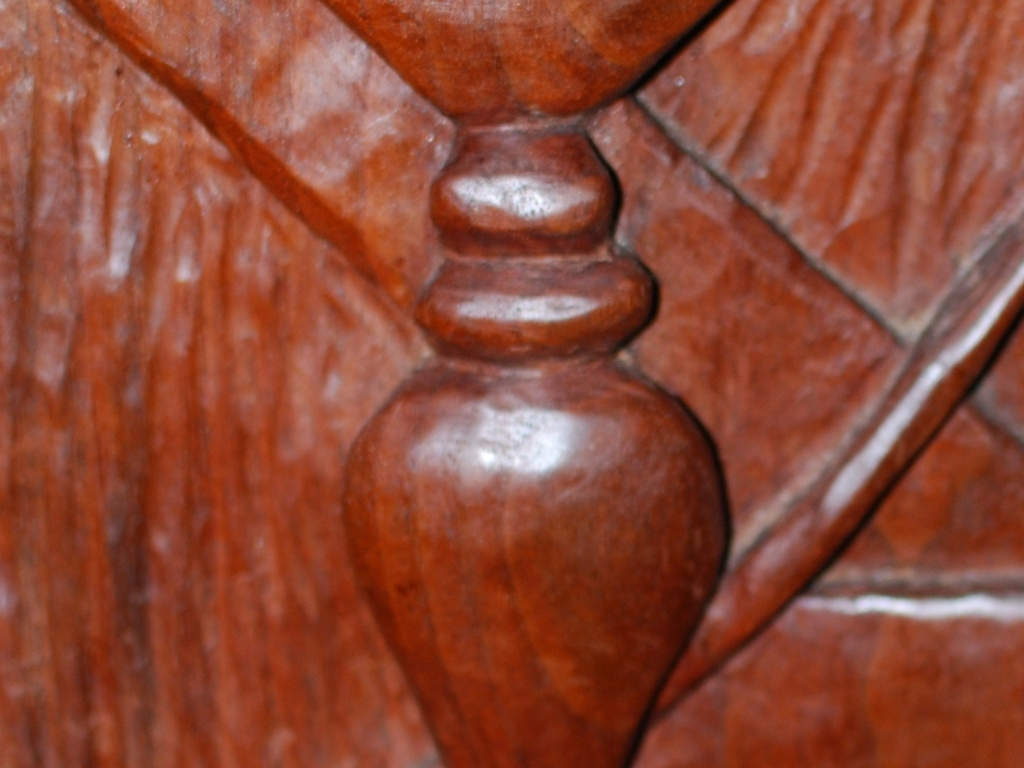How would you describe the quality of this image? The image is of suboptimal quality due to its lack of sharpness, which might be the result of low focus or camera movement during capture. Additionally, the close-up perspective makes it difficult to understand the context or identify the object fully. 